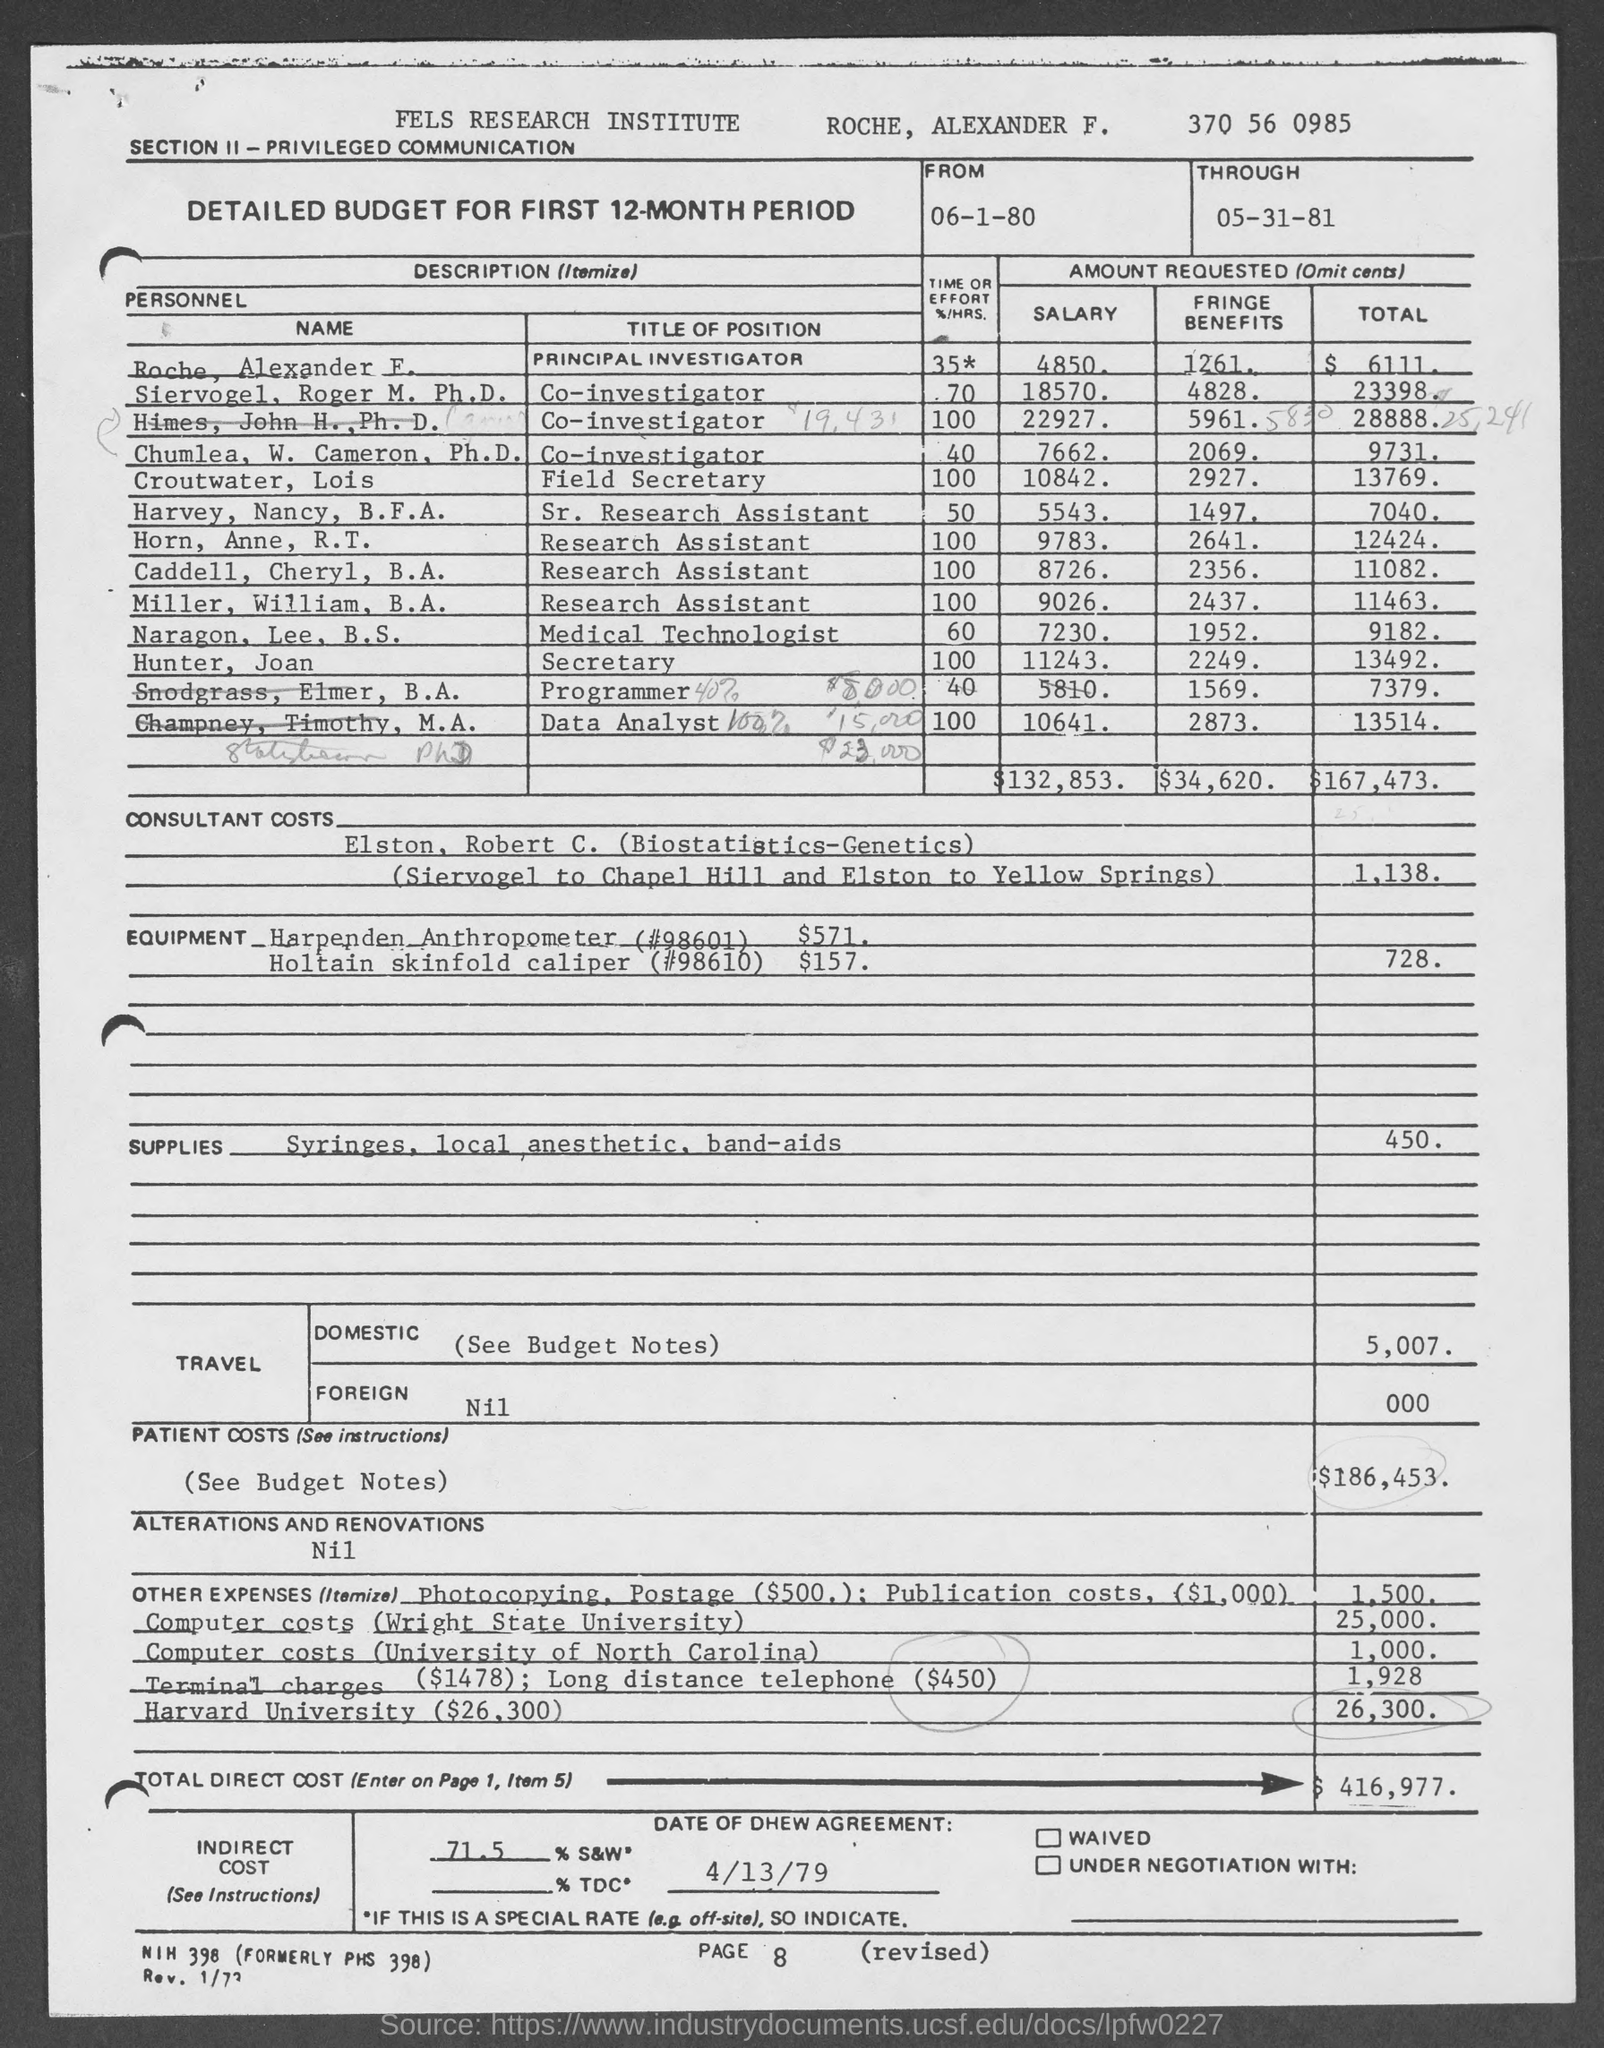Highlight a few significant elements in this photo. The through date is May 31st, 1981. Hunter and Joan have requested a total of 13492 units. The salary of Croutwater, Lois is 10,842. The field secretary is named Croutwater and their name is followed by Lois. The Fels Research Institute is the name of the Institute. 